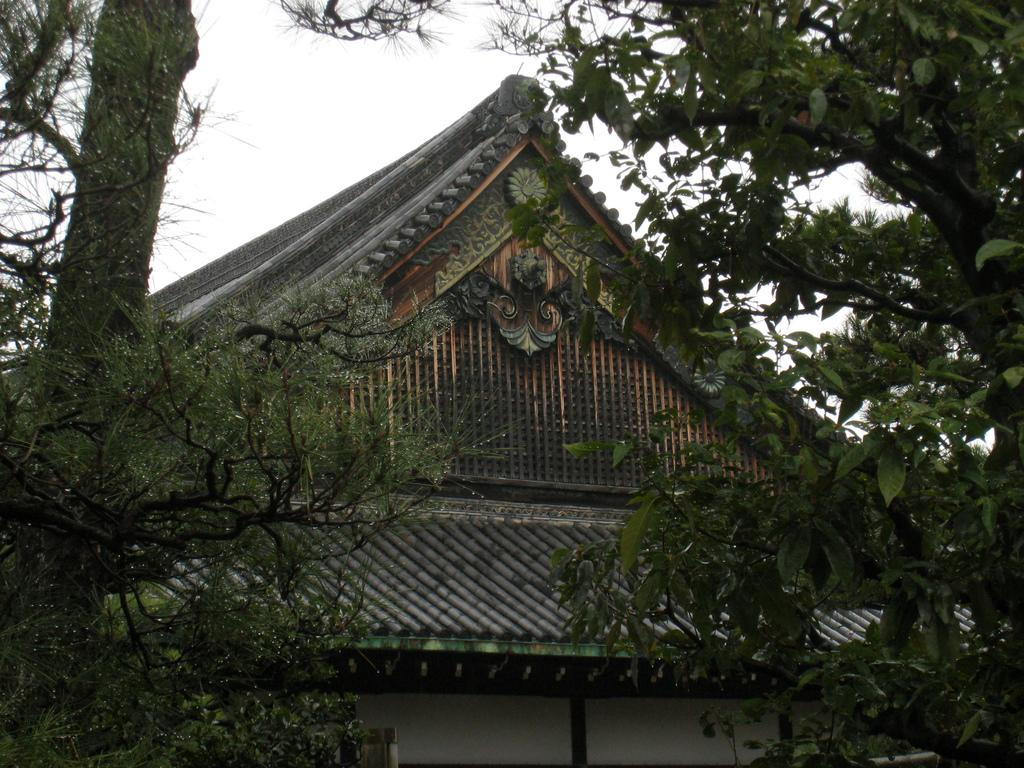What type of vegetation is visible in the image? There are trees in the image. What type of man-made structures can be seen in the image? There are buildings in the image. What is visible at the top of the image? The sky is visible at the top of the image. What time is depicted in the image? The image does not show a specific time; it is a static representation. Can you see any grapes growing on the trees in the image? There are no grapes visible in the image; only trees and buildings are present. 